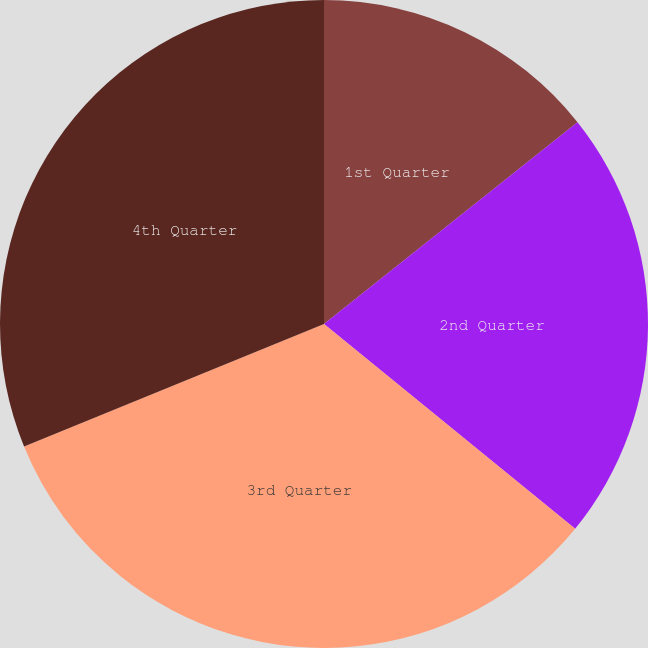Convert chart to OTSL. <chart><loc_0><loc_0><loc_500><loc_500><pie_chart><fcel>1st Quarter<fcel>2nd Quarter<fcel>3rd Quarter<fcel>4th Quarter<nl><fcel>14.3%<fcel>21.58%<fcel>32.94%<fcel>31.17%<nl></chart> 